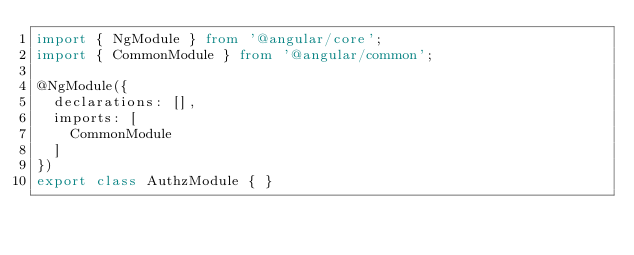<code> <loc_0><loc_0><loc_500><loc_500><_TypeScript_>import { NgModule } from '@angular/core';
import { CommonModule } from '@angular/common';

@NgModule({
  declarations: [],
  imports: [
    CommonModule
  ]
})
export class AuthzModule { }
</code> 